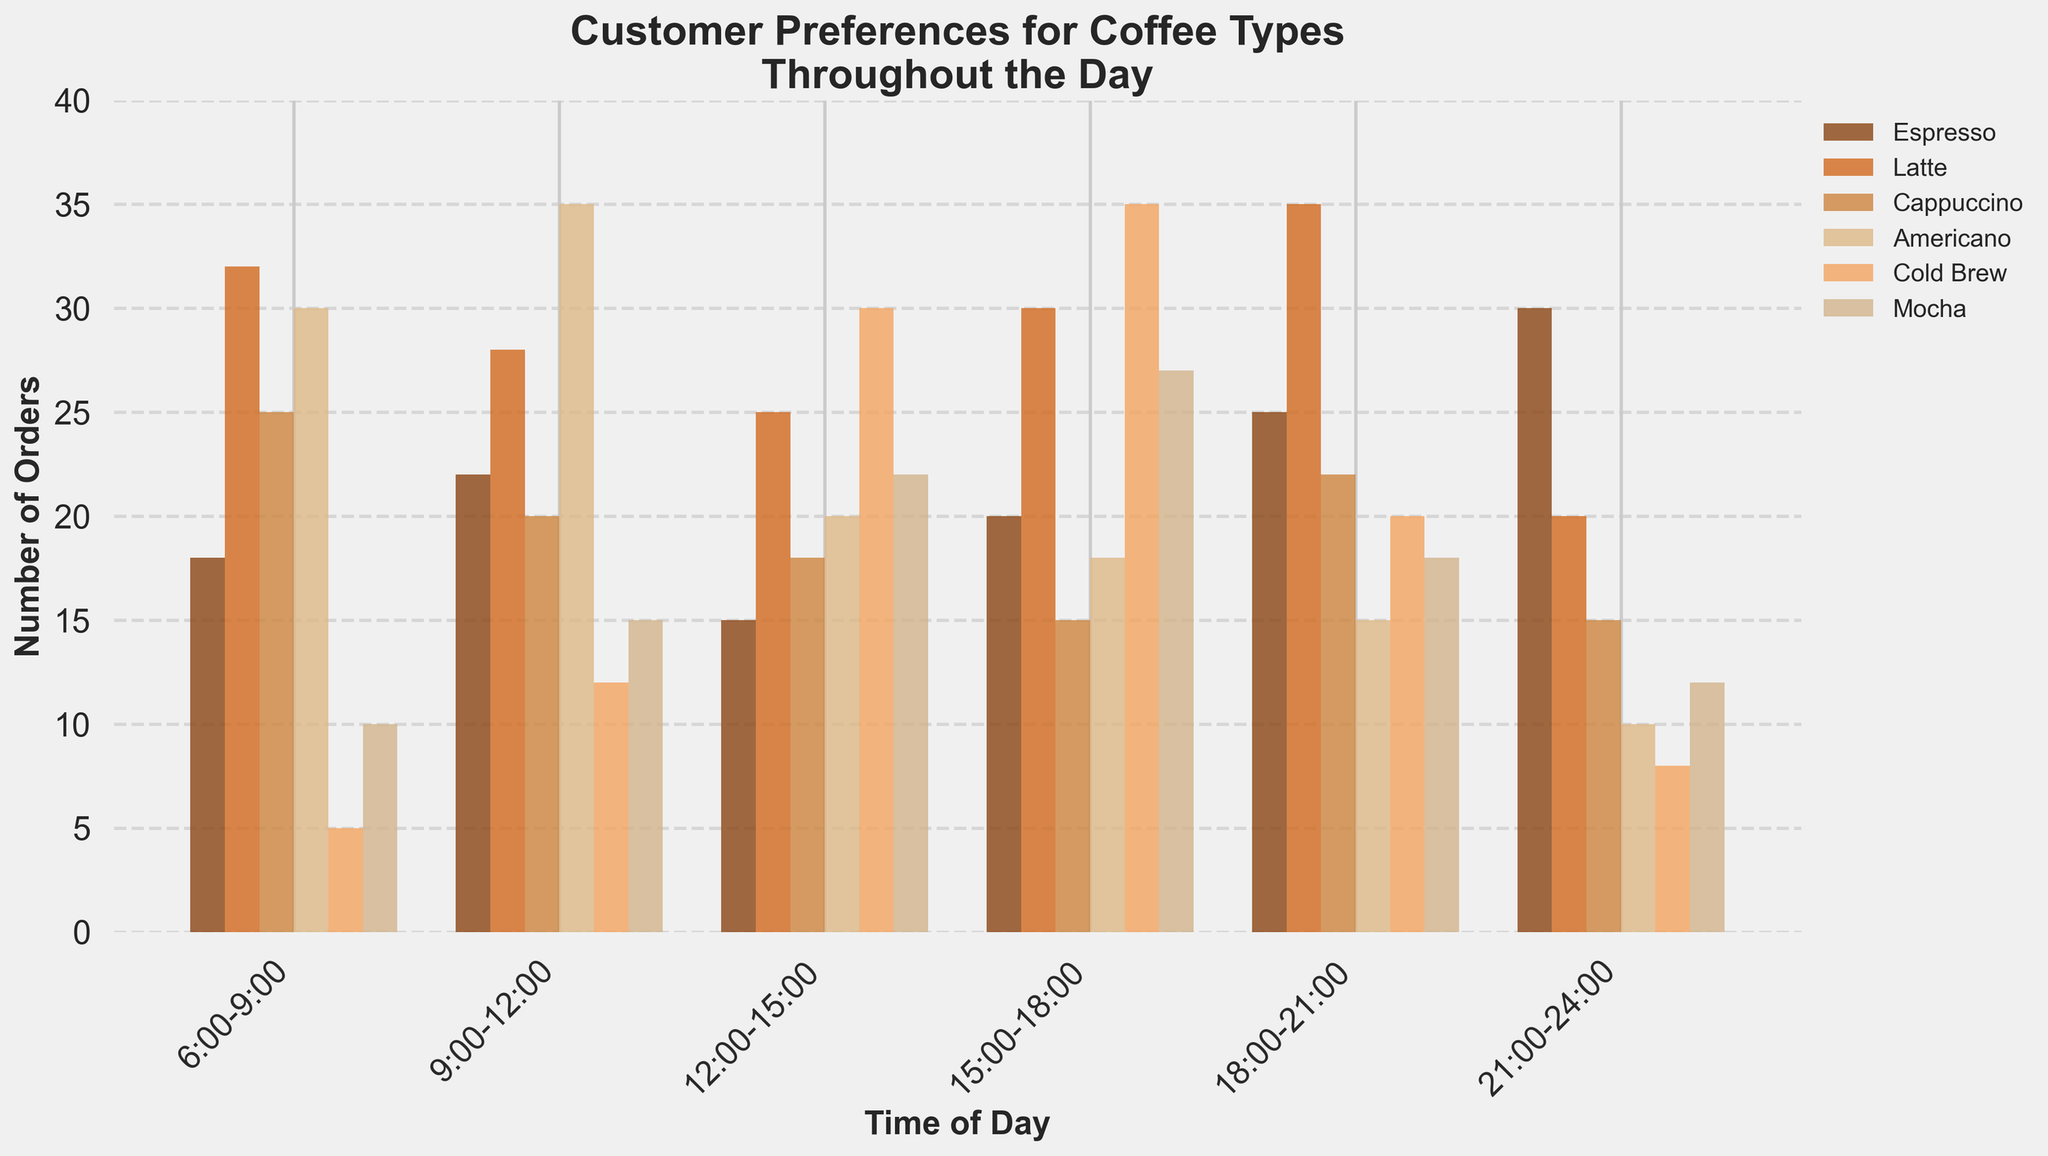Which coffee type is most preferred during 6:00-9:00? Look for the tallest bar in the time slot 6:00-9:00. The latte bar is the tallest with 32 orders.
Answer: Latte During which time slot is Cold Brew most preferred? Check all the bars for Cold Brew and identify which one is the tallest. The tallest Cold Brew bar is in the 15:00-18:00 slot with 35 orders.
Answer: 15:00-18:00 Compare the total number of Espresso orders in the morning (6:00-9:00 and 9:00-12:00) to those in the evening (18:00-21:00 and 21:00-24:00). Which is higher? Sum up the Espresso orders for 6:00-9:00 and 9:00-12:00 (18 + 22 = 40), then for 18:00-21:00 and 21:00-24:00 (25 + 30 = 55). Compare 40 and 55.
Answer: Evening Which coffee type has its highest number of orders in the 18:00-21:00 slot? Check each coffee type's bar in the 18:00-21:00 slot and see which one has the highest value. The Latte reaches 35 orders.
Answer: Latte What is the combined total of Cappuccino orders throughout the day? Sum up the Cappuccino orders from all time slots (25 + 20 + 18 + 15 + 22 + 15 = 115).
Answer: 115 During which time slot is Mocha least preferred? Identify the Mocha bars and find the shortest one. The shortest Mocha bar is during 6:00-9:00 with 10 orders.
Answer: 6:00-9:00 Which has more orders in the 12:00-15:00 slot, Americano or Cold Brew? Compare the heights of the Americano and Cold Brew bars for 12:00-15:00. Americano has 20 orders while Cold Brew has 30.
Answer: Cold Brew During which time slots are there more Latte orders than Espresso orders? For each time slot, compare the heights of the Latte and Espresso bars. The time slots with more Latte orders are 6:00-9:00, 9:00-12:00, 12:00-15:00, 15:00-18:00, and 18:00-21:00.
Answer: 6:00-9:00, 9:00-12:00, 12:00-15:00, 15:00-18:00, 18:00-21:00 What is the average number of Americano orders from 6:00 to 18:00? Sum the Americano orders from 6:00-18:00 (30 + 35 + 20 + 18) and divide by the number of time slots (4). (103 / 4 = 25.75)
Answer: 25.75 Which coffee type's number of orders fluctuates the most throughout the day? Evaluate the range (difference between max and min) of each coffee type's orders. Espresso ranges from 15 to 30, Latte ranges from 20 to 35, Cappuccino ranges from 15 to 25, Americano ranges from 10 to 35, Cold Brew ranges from 5 to 35, and Mocha ranges from 10 to 27. The largest fluctuation is for Cold Brew (30 orders).
Answer: Cold Brew 